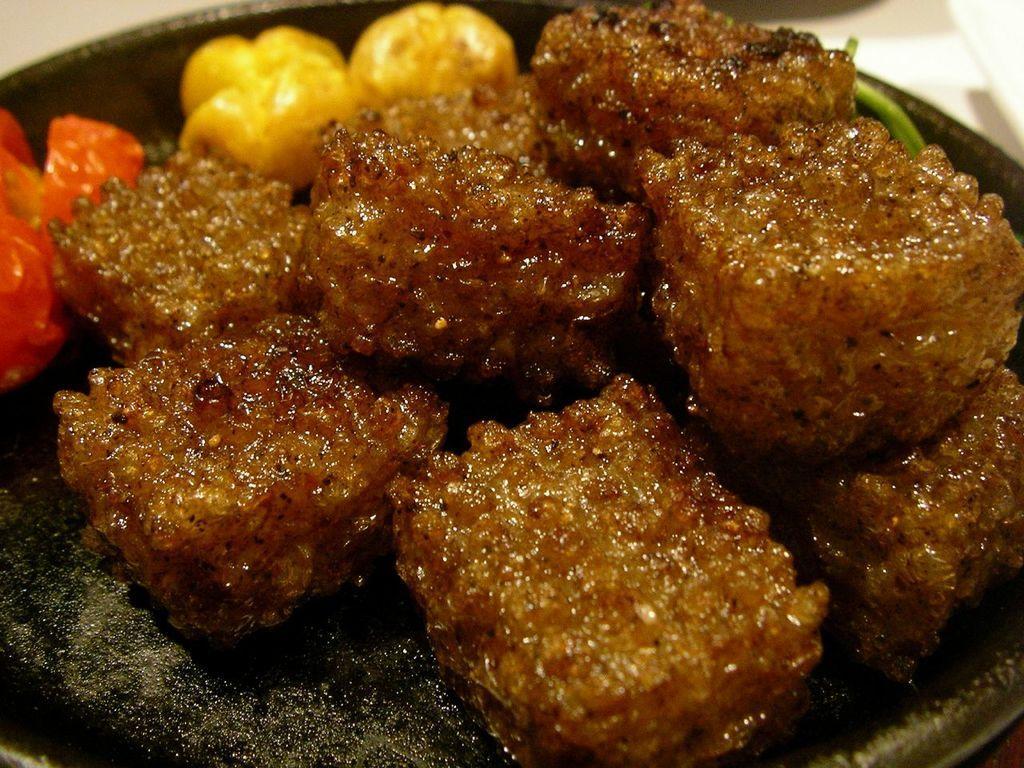Could you give a brief overview of what you see in this image? In the image in the center we can see one plate. In plate,we can see some food item. 